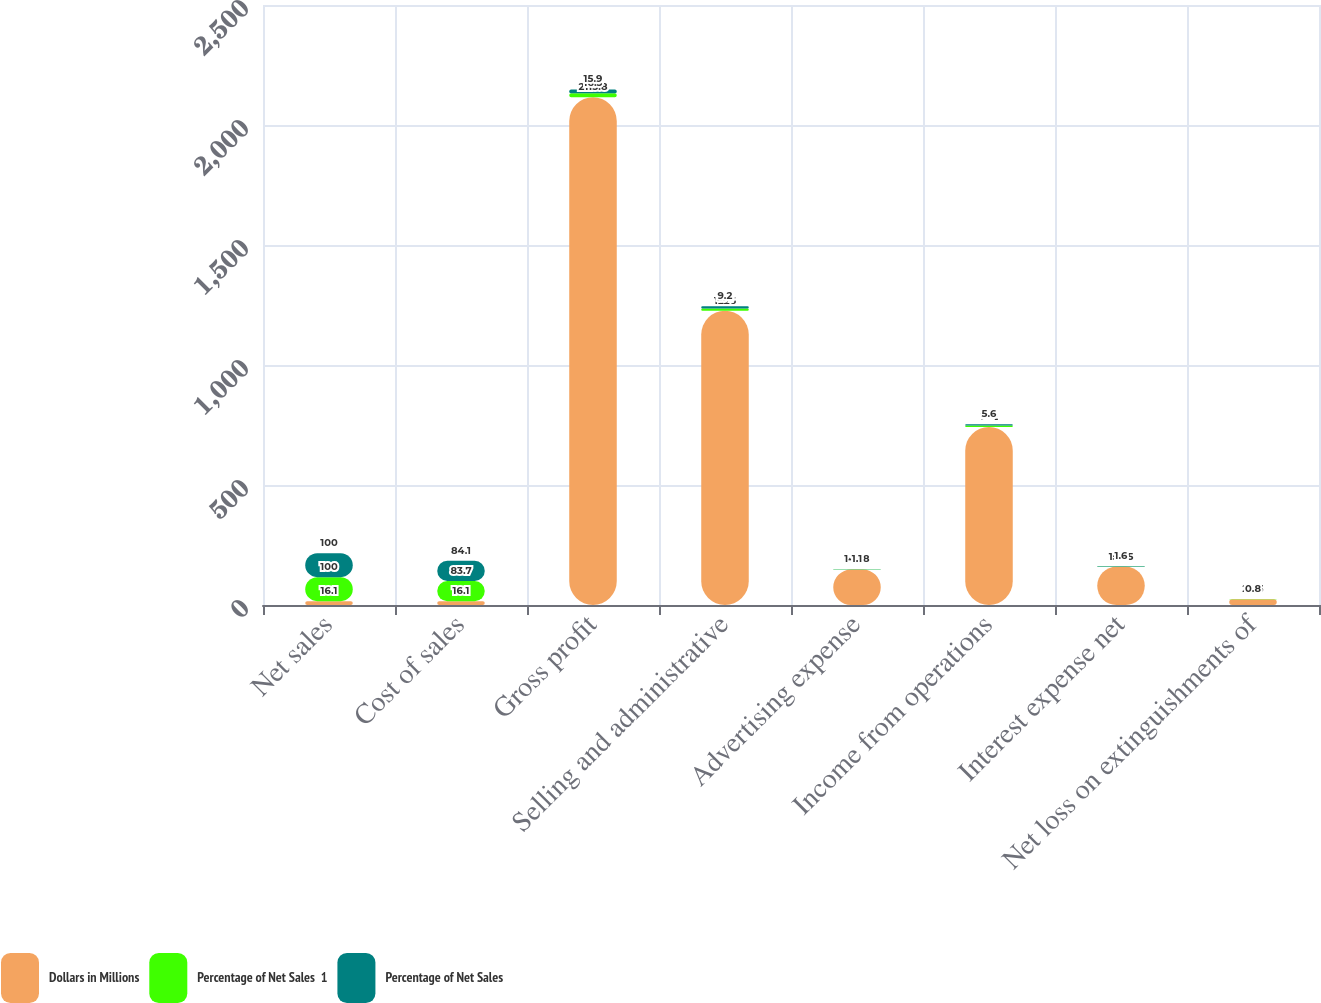Convert chart. <chart><loc_0><loc_0><loc_500><loc_500><stacked_bar_chart><ecel><fcel>Net sales<fcel>Cost of sales<fcel>Gross profit<fcel>Selling and administrative<fcel>Advertising expense<fcel>Income from operations<fcel>Interest expense net<fcel>Net loss on extinguishments of<nl><fcel>Dollars in Millions<fcel>16.1<fcel>16.1<fcel>2115.8<fcel>1226<fcel>147.8<fcel>742<fcel>159.5<fcel>24.3<nl><fcel>Percentage of Net Sales  1<fcel>100<fcel>83.7<fcel>16.3<fcel>9.4<fcel>1.1<fcel>5.7<fcel>1.2<fcel>0.2<nl><fcel>Percentage of Net Sales<fcel>100<fcel>84.1<fcel>15.9<fcel>9.2<fcel>1.1<fcel>5.6<fcel>1.6<fcel>0.8<nl></chart> 